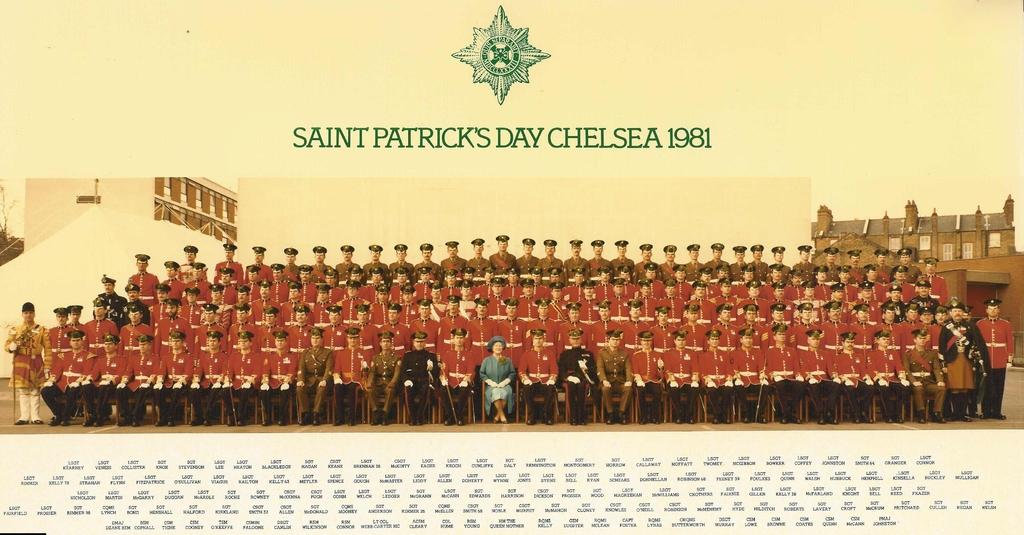<image>
Share a concise interpretation of the image provided. A photo of men wearing red military jackets from Saint Patrick's Day Chelsea 1981. 